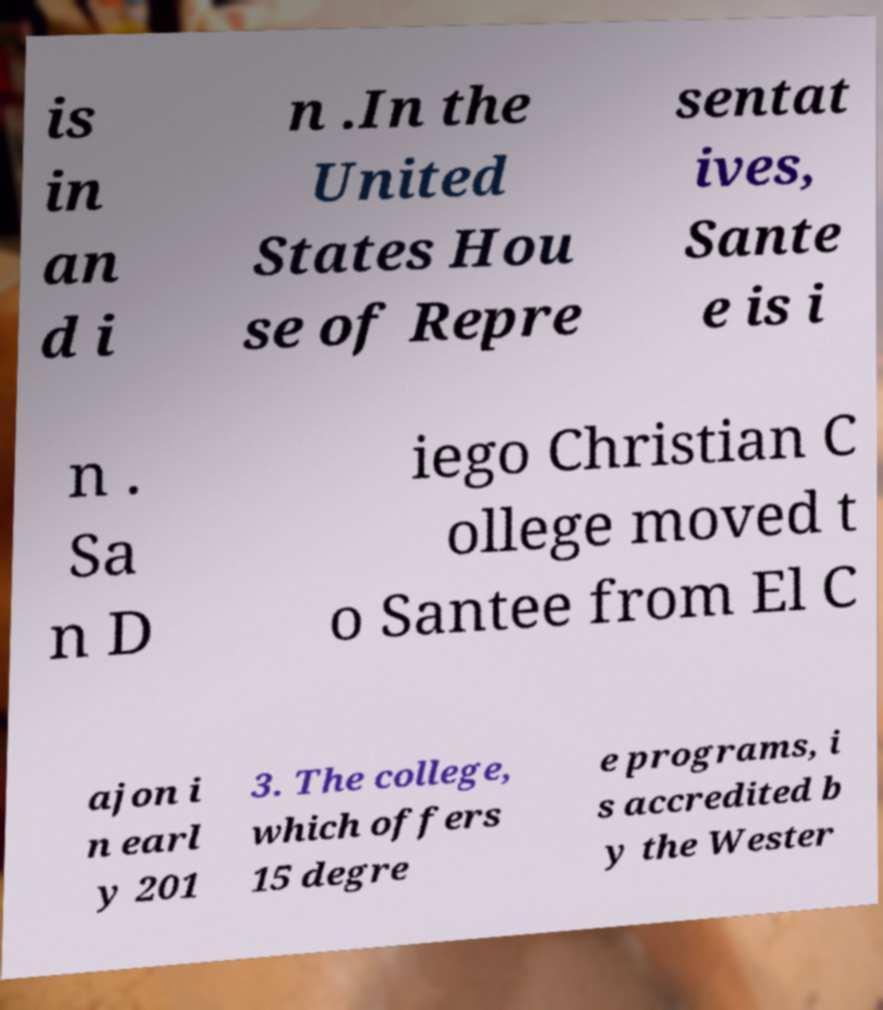Could you extract and type out the text from this image? is in an d i n .In the United States Hou se of Repre sentat ives, Sante e is i n . Sa n D iego Christian C ollege moved t o Santee from El C ajon i n earl y 201 3. The college, which offers 15 degre e programs, i s accredited b y the Wester 